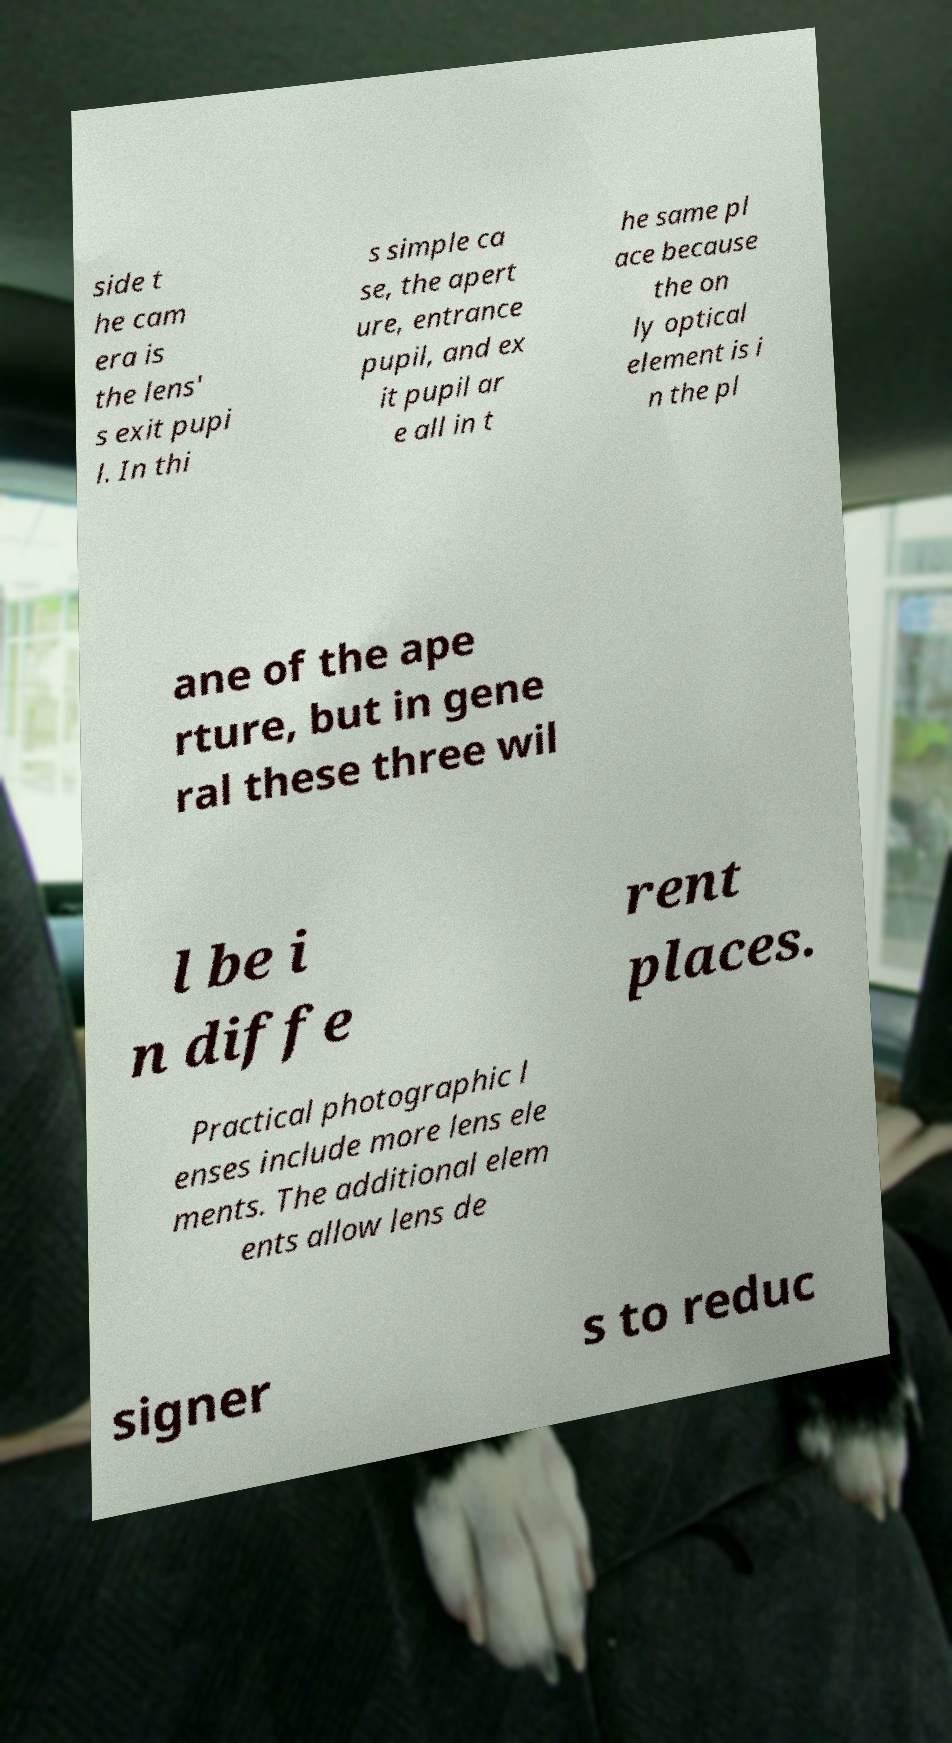For documentation purposes, I need the text within this image transcribed. Could you provide that? side t he cam era is the lens' s exit pupi l. In thi s simple ca se, the apert ure, entrance pupil, and ex it pupil ar e all in t he same pl ace because the on ly optical element is i n the pl ane of the ape rture, but in gene ral these three wil l be i n diffe rent places. Practical photographic l enses include more lens ele ments. The additional elem ents allow lens de signer s to reduc 